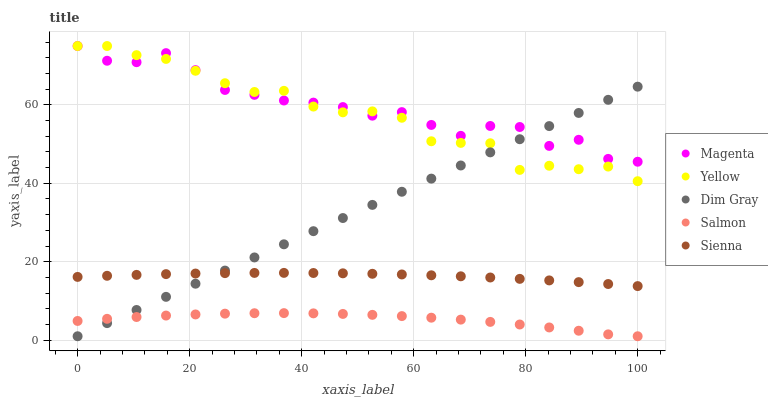Does Salmon have the minimum area under the curve?
Answer yes or no. Yes. Does Magenta have the maximum area under the curve?
Answer yes or no. Yes. Does Dim Gray have the minimum area under the curve?
Answer yes or no. No. Does Dim Gray have the maximum area under the curve?
Answer yes or no. No. Is Dim Gray the smoothest?
Answer yes or no. Yes. Is Magenta the roughest?
Answer yes or no. Yes. Is Magenta the smoothest?
Answer yes or no. No. Is Dim Gray the roughest?
Answer yes or no. No. Does Dim Gray have the lowest value?
Answer yes or no. Yes. Does Magenta have the lowest value?
Answer yes or no. No. Does Yellow have the highest value?
Answer yes or no. Yes. Does Dim Gray have the highest value?
Answer yes or no. No. Is Salmon less than Yellow?
Answer yes or no. Yes. Is Yellow greater than Sienna?
Answer yes or no. Yes. Does Magenta intersect Yellow?
Answer yes or no. Yes. Is Magenta less than Yellow?
Answer yes or no. No. Is Magenta greater than Yellow?
Answer yes or no. No. Does Salmon intersect Yellow?
Answer yes or no. No. 